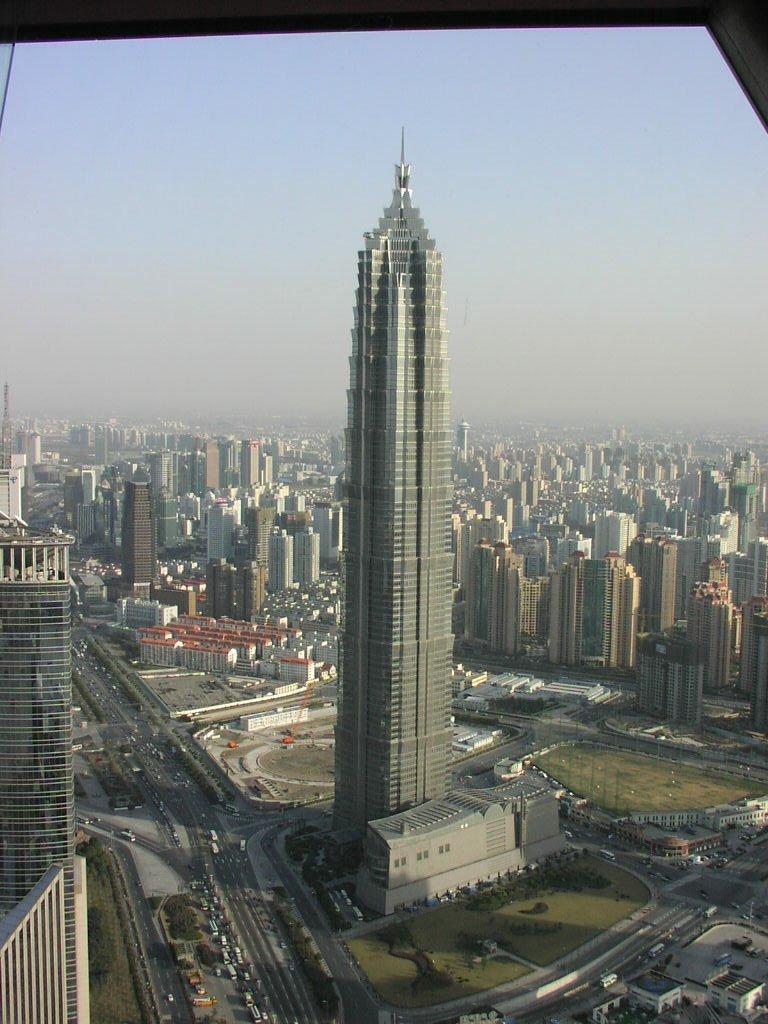Describe this image in one or two sentences. On the left side, there are buildings and there are vehicles on the road. In the middle of the image, there is a tower. On the right side, there are plants and grass on the ground, vehicles on the road and there are buildings. In the background, there are buildings and there are clouds in the sky. 